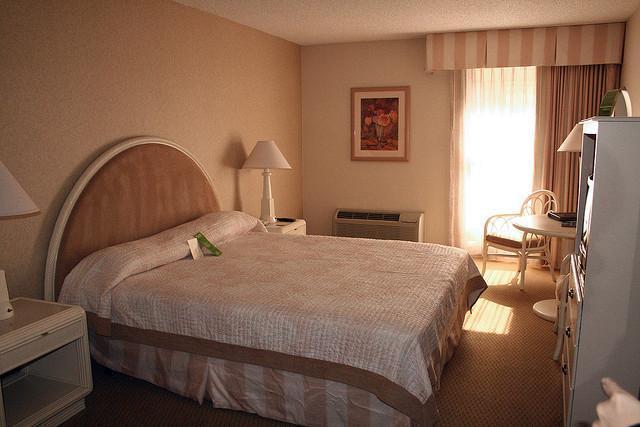What venue is shown here?
Make your selection from the four choices given to correctly answer the question.
Options: Hotel room, apartment, studio, bedroom. Hotel room. What type of establishment is known to put notecards on beds like this?
Indicate the correct response and explain using: 'Answer: answer
Rationale: rationale.'
Options: Hotels, arenas, lobbies, parks. Answer: hotels.
Rationale: Hotels have touches in their rooms such as welcome cards. the bed is perfectly made with a note on the bed. 